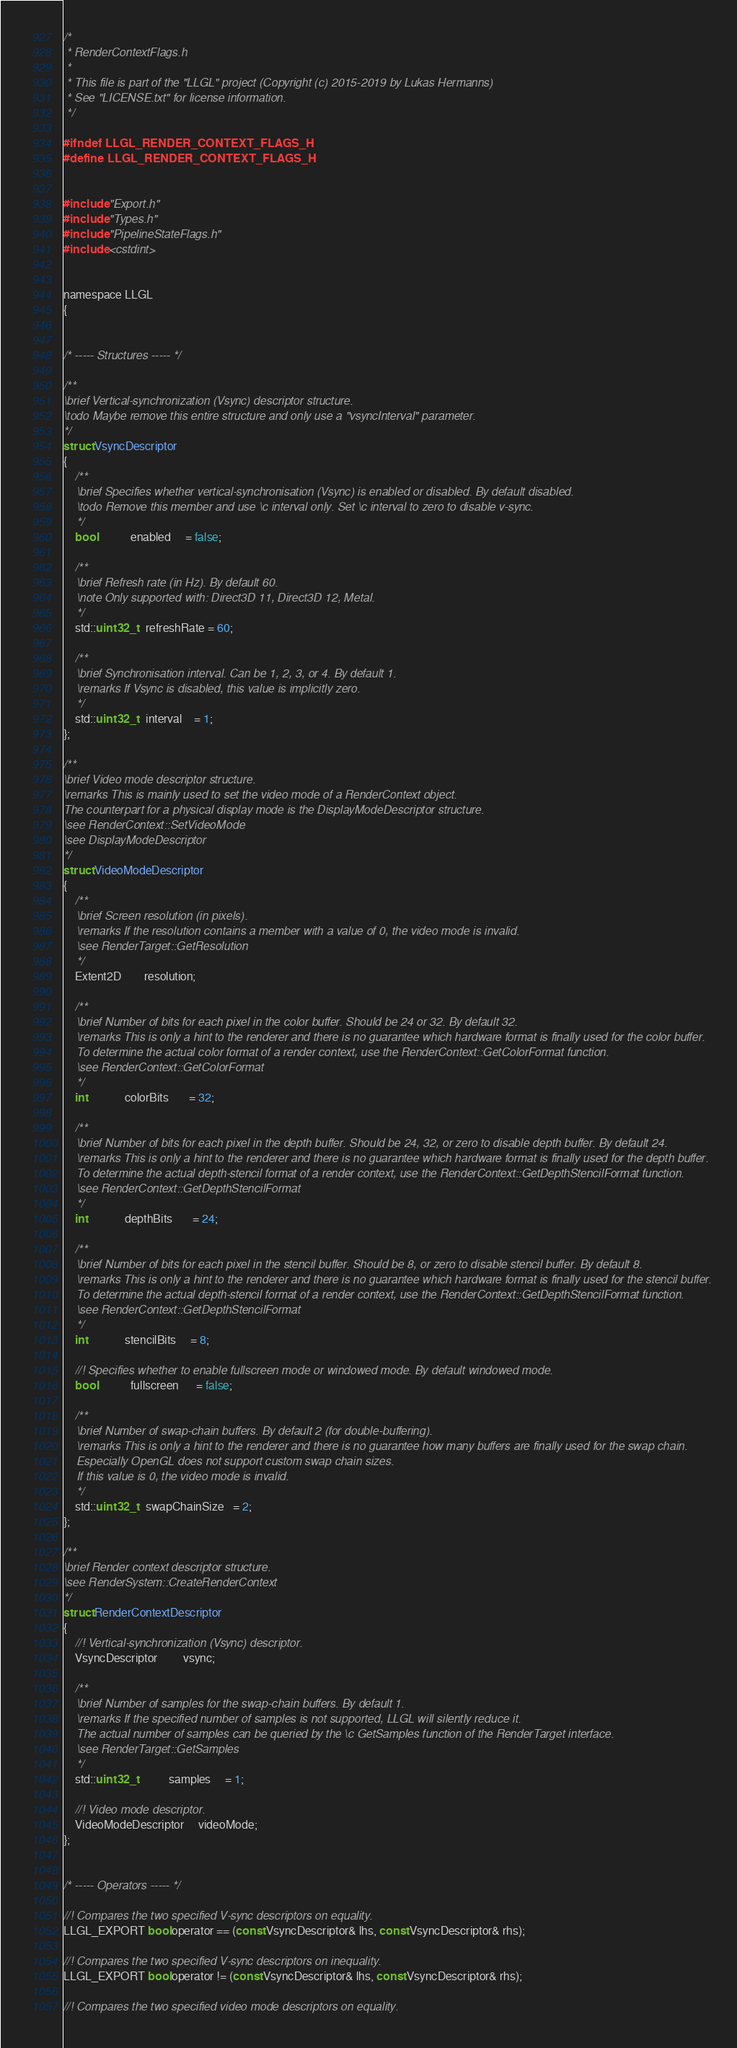<code> <loc_0><loc_0><loc_500><loc_500><_C_>/*
 * RenderContextFlags.h
 * 
 * This file is part of the "LLGL" project (Copyright (c) 2015-2019 by Lukas Hermanns)
 * See "LICENSE.txt" for license information.
 */

#ifndef LLGL_RENDER_CONTEXT_FLAGS_H
#define LLGL_RENDER_CONTEXT_FLAGS_H


#include "Export.h"
#include "Types.h"
#include "PipelineStateFlags.h"
#include <cstdint>


namespace LLGL
{


/* ----- Structures ----- */

/**
\brief Vertical-synchronization (Vsync) descriptor structure.
\todo Maybe remove this entire structure and only use a "vsyncInterval" parameter.
*/
struct VsyncDescriptor
{
    /**
    \brief Specifies whether vertical-synchronisation (Vsync) is enabled or disabled. By default disabled.
    \todo Remove this member and use \c interval only. Set \c interval to zero to disable v-sync.
    */
    bool            enabled     = false;

    /**
    \brief Refresh rate (in Hz). By default 60.
    \note Only supported with: Direct3D 11, Direct3D 12, Metal.
    */
    std::uint32_t   refreshRate = 60;

    /**
    \brief Synchronisation interval. Can be 1, 2, 3, or 4. By default 1.
    \remarks If Vsync is disabled, this value is implicitly zero.
    */
    std::uint32_t   interval    = 1;
};

/**
\brief Video mode descriptor structure.
\remarks This is mainly used to set the video mode of a RenderContext object.
The counterpart for a physical display mode is the DisplayModeDescriptor structure.
\see RenderContext::SetVideoMode
\see DisplayModeDescriptor
*/
struct VideoModeDescriptor
{
    /**
    \brief Screen resolution (in pixels).
    \remarks If the resolution contains a member with a value of 0, the video mode is invalid.
    \see RenderTarget::GetResolution
    */
    Extent2D        resolution;

    /**
    \brief Number of bits for each pixel in the color buffer. Should be 24 or 32. By default 32.
    \remarks This is only a hint to the renderer and there is no guarantee which hardware format is finally used for the color buffer.
    To determine the actual color format of a render context, use the RenderContext::GetColorFormat function.
    \see RenderContext::GetColorFormat
    */
    int             colorBits       = 32;

    /**
    \brief Number of bits for each pixel in the depth buffer. Should be 24, 32, or zero to disable depth buffer. By default 24.
    \remarks This is only a hint to the renderer and there is no guarantee which hardware format is finally used for the depth buffer.
    To determine the actual depth-stencil format of a render context, use the RenderContext::GetDepthStencilFormat function.
    \see RenderContext::GetDepthStencilFormat
    */
    int             depthBits       = 24;

    /**
    \brief Number of bits for each pixel in the stencil buffer. Should be 8, or zero to disable stencil buffer. By default 8.
    \remarks This is only a hint to the renderer and there is no guarantee which hardware format is finally used for the stencil buffer.
    To determine the actual depth-stencil format of a render context, use the RenderContext::GetDepthStencilFormat function.
    \see RenderContext::GetDepthStencilFormat
    */
    int             stencilBits     = 8;

    //! Specifies whether to enable fullscreen mode or windowed mode. By default windowed mode.
    bool            fullscreen      = false;

    /**
    \brief Number of swap-chain buffers. By default 2 (for double-buffering).
    \remarks This is only a hint to the renderer and there is no guarantee how many buffers are finally used for the swap chain.
    Especially OpenGL does not support custom swap chain sizes.
    If this value is 0, the video mode is invalid.
    */
    std::uint32_t   swapChainSize   = 2;
};

/**
\brief Render context descriptor structure.
\see RenderSystem::CreateRenderContext
*/
struct RenderContextDescriptor
{
    //! Vertical-synchronization (Vsync) descriptor.
    VsyncDescriptor         vsync;

    /**
    \brief Number of samples for the swap-chain buffers. By default 1.
    \remarks If the specified number of samples is not supported, LLGL will silently reduce it.
    The actual number of samples can be queried by the \c GetSamples function of the RenderTarget interface.
    \see RenderTarget::GetSamples
    */
    std::uint32_t           samples     = 1;

    //! Video mode descriptor.
    VideoModeDescriptor     videoMode;
};


/* ----- Operators ----- */

//! Compares the two specified V-sync descriptors on equality.
LLGL_EXPORT bool operator == (const VsyncDescriptor& lhs, const VsyncDescriptor& rhs);

//! Compares the two specified V-sync descriptors on inequality.
LLGL_EXPORT bool operator != (const VsyncDescriptor& lhs, const VsyncDescriptor& rhs);

//! Compares the two specified video mode descriptors on equality.</code> 